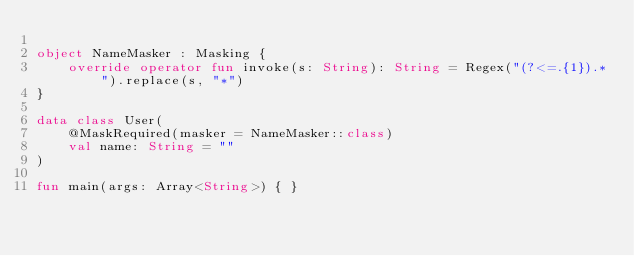<code> <loc_0><loc_0><loc_500><loc_500><_Kotlin_>
object NameMasker : Masking {
    override operator fun invoke(s: String): String = Regex("(?<=.{1}).*").replace(s, "*")
}

data class User(
    @MaskRequired(masker = NameMasker::class)
    val name: String = ""
)

fun main(args: Array<String>) { }</code> 